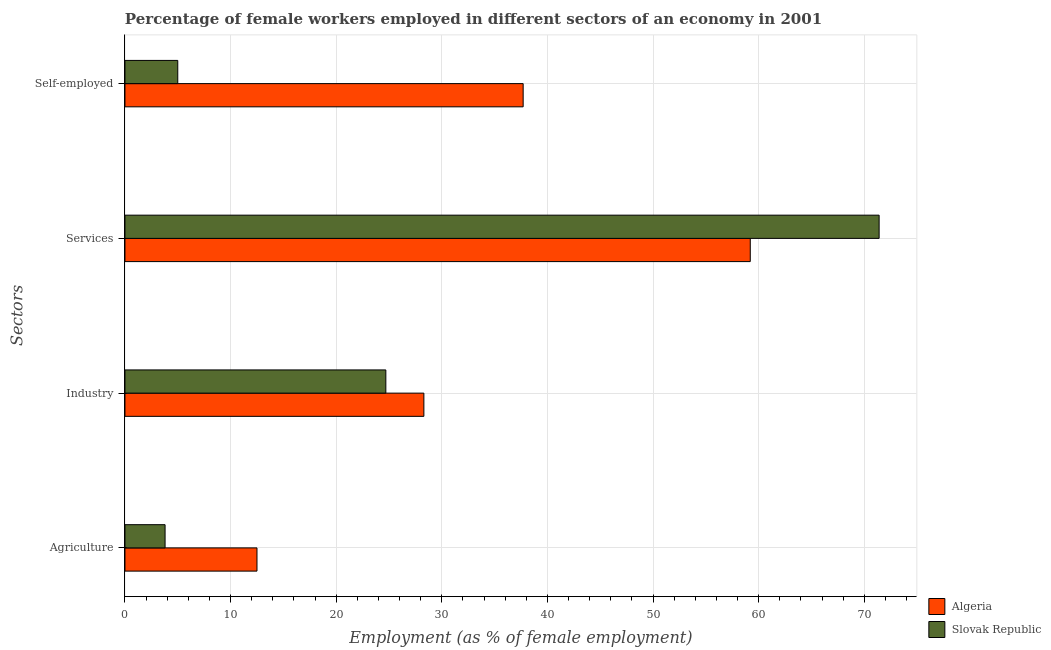How many different coloured bars are there?
Keep it short and to the point. 2. How many groups of bars are there?
Provide a succinct answer. 4. Are the number of bars per tick equal to the number of legend labels?
Keep it short and to the point. Yes. How many bars are there on the 2nd tick from the bottom?
Make the answer very short. 2. What is the label of the 1st group of bars from the top?
Give a very brief answer. Self-employed. What is the percentage of female workers in services in Algeria?
Provide a succinct answer. 59.2. Across all countries, what is the maximum percentage of female workers in agriculture?
Give a very brief answer. 12.5. In which country was the percentage of female workers in agriculture maximum?
Your answer should be compact. Algeria. In which country was the percentage of female workers in agriculture minimum?
Give a very brief answer. Slovak Republic. What is the total percentage of self employed female workers in the graph?
Your response must be concise. 42.7. What is the difference between the percentage of female workers in agriculture in Slovak Republic and that in Algeria?
Offer a terse response. -8.7. What is the difference between the percentage of self employed female workers in Slovak Republic and the percentage of female workers in services in Algeria?
Ensure brevity in your answer.  -54.2. What is the average percentage of female workers in services per country?
Your answer should be compact. 65.3. What is the difference between the percentage of self employed female workers and percentage of female workers in industry in Algeria?
Make the answer very short. 9.4. In how many countries, is the percentage of female workers in services greater than 4 %?
Make the answer very short. 2. What is the ratio of the percentage of female workers in industry in Algeria to that in Slovak Republic?
Provide a succinct answer. 1.15. What is the difference between the highest and the second highest percentage of self employed female workers?
Give a very brief answer. 32.7. What is the difference between the highest and the lowest percentage of self employed female workers?
Your answer should be very brief. 32.7. Is it the case that in every country, the sum of the percentage of female workers in agriculture and percentage of self employed female workers is greater than the sum of percentage of female workers in services and percentage of female workers in industry?
Make the answer very short. No. What does the 2nd bar from the top in Industry represents?
Your answer should be very brief. Algeria. What does the 1st bar from the bottom in Agriculture represents?
Provide a succinct answer. Algeria. Is it the case that in every country, the sum of the percentage of female workers in agriculture and percentage of female workers in industry is greater than the percentage of female workers in services?
Make the answer very short. No. How many countries are there in the graph?
Provide a succinct answer. 2. What is the difference between two consecutive major ticks on the X-axis?
Make the answer very short. 10. Does the graph contain any zero values?
Offer a terse response. No. How many legend labels are there?
Make the answer very short. 2. How are the legend labels stacked?
Your answer should be very brief. Vertical. What is the title of the graph?
Your answer should be very brief. Percentage of female workers employed in different sectors of an economy in 2001. What is the label or title of the X-axis?
Ensure brevity in your answer.  Employment (as % of female employment). What is the label or title of the Y-axis?
Keep it short and to the point. Sectors. What is the Employment (as % of female employment) in Algeria in Agriculture?
Offer a terse response. 12.5. What is the Employment (as % of female employment) of Slovak Republic in Agriculture?
Keep it short and to the point. 3.8. What is the Employment (as % of female employment) in Algeria in Industry?
Ensure brevity in your answer.  28.3. What is the Employment (as % of female employment) in Slovak Republic in Industry?
Your response must be concise. 24.7. What is the Employment (as % of female employment) of Algeria in Services?
Offer a terse response. 59.2. What is the Employment (as % of female employment) in Slovak Republic in Services?
Provide a short and direct response. 71.4. What is the Employment (as % of female employment) in Algeria in Self-employed?
Your response must be concise. 37.7. Across all Sectors, what is the maximum Employment (as % of female employment) of Algeria?
Your response must be concise. 59.2. Across all Sectors, what is the maximum Employment (as % of female employment) of Slovak Republic?
Provide a short and direct response. 71.4. Across all Sectors, what is the minimum Employment (as % of female employment) in Slovak Republic?
Offer a terse response. 3.8. What is the total Employment (as % of female employment) of Algeria in the graph?
Your answer should be compact. 137.7. What is the total Employment (as % of female employment) in Slovak Republic in the graph?
Your answer should be compact. 104.9. What is the difference between the Employment (as % of female employment) in Algeria in Agriculture and that in Industry?
Keep it short and to the point. -15.8. What is the difference between the Employment (as % of female employment) in Slovak Republic in Agriculture and that in Industry?
Provide a short and direct response. -20.9. What is the difference between the Employment (as % of female employment) in Algeria in Agriculture and that in Services?
Offer a very short reply. -46.7. What is the difference between the Employment (as % of female employment) of Slovak Republic in Agriculture and that in Services?
Your answer should be compact. -67.6. What is the difference between the Employment (as % of female employment) of Algeria in Agriculture and that in Self-employed?
Offer a terse response. -25.2. What is the difference between the Employment (as % of female employment) in Slovak Republic in Agriculture and that in Self-employed?
Provide a short and direct response. -1.2. What is the difference between the Employment (as % of female employment) in Algeria in Industry and that in Services?
Your answer should be compact. -30.9. What is the difference between the Employment (as % of female employment) of Slovak Republic in Industry and that in Services?
Keep it short and to the point. -46.7. What is the difference between the Employment (as % of female employment) of Algeria in Industry and that in Self-employed?
Provide a succinct answer. -9.4. What is the difference between the Employment (as % of female employment) of Slovak Republic in Industry and that in Self-employed?
Make the answer very short. 19.7. What is the difference between the Employment (as % of female employment) of Algeria in Services and that in Self-employed?
Your answer should be compact. 21.5. What is the difference between the Employment (as % of female employment) in Slovak Republic in Services and that in Self-employed?
Provide a short and direct response. 66.4. What is the difference between the Employment (as % of female employment) of Algeria in Agriculture and the Employment (as % of female employment) of Slovak Republic in Services?
Make the answer very short. -58.9. What is the difference between the Employment (as % of female employment) of Algeria in Agriculture and the Employment (as % of female employment) of Slovak Republic in Self-employed?
Keep it short and to the point. 7.5. What is the difference between the Employment (as % of female employment) of Algeria in Industry and the Employment (as % of female employment) of Slovak Republic in Services?
Ensure brevity in your answer.  -43.1. What is the difference between the Employment (as % of female employment) in Algeria in Industry and the Employment (as % of female employment) in Slovak Republic in Self-employed?
Provide a short and direct response. 23.3. What is the difference between the Employment (as % of female employment) in Algeria in Services and the Employment (as % of female employment) in Slovak Republic in Self-employed?
Ensure brevity in your answer.  54.2. What is the average Employment (as % of female employment) in Algeria per Sectors?
Your response must be concise. 34.42. What is the average Employment (as % of female employment) of Slovak Republic per Sectors?
Provide a short and direct response. 26.23. What is the difference between the Employment (as % of female employment) of Algeria and Employment (as % of female employment) of Slovak Republic in Agriculture?
Offer a terse response. 8.7. What is the difference between the Employment (as % of female employment) of Algeria and Employment (as % of female employment) of Slovak Republic in Self-employed?
Make the answer very short. 32.7. What is the ratio of the Employment (as % of female employment) of Algeria in Agriculture to that in Industry?
Give a very brief answer. 0.44. What is the ratio of the Employment (as % of female employment) of Slovak Republic in Agriculture to that in Industry?
Keep it short and to the point. 0.15. What is the ratio of the Employment (as % of female employment) of Algeria in Agriculture to that in Services?
Ensure brevity in your answer.  0.21. What is the ratio of the Employment (as % of female employment) of Slovak Republic in Agriculture to that in Services?
Your answer should be compact. 0.05. What is the ratio of the Employment (as % of female employment) of Algeria in Agriculture to that in Self-employed?
Your answer should be very brief. 0.33. What is the ratio of the Employment (as % of female employment) of Slovak Republic in Agriculture to that in Self-employed?
Provide a short and direct response. 0.76. What is the ratio of the Employment (as % of female employment) in Algeria in Industry to that in Services?
Keep it short and to the point. 0.48. What is the ratio of the Employment (as % of female employment) in Slovak Republic in Industry to that in Services?
Keep it short and to the point. 0.35. What is the ratio of the Employment (as % of female employment) of Algeria in Industry to that in Self-employed?
Ensure brevity in your answer.  0.75. What is the ratio of the Employment (as % of female employment) in Slovak Republic in Industry to that in Self-employed?
Your answer should be very brief. 4.94. What is the ratio of the Employment (as % of female employment) of Algeria in Services to that in Self-employed?
Offer a very short reply. 1.57. What is the ratio of the Employment (as % of female employment) in Slovak Republic in Services to that in Self-employed?
Ensure brevity in your answer.  14.28. What is the difference between the highest and the second highest Employment (as % of female employment) in Algeria?
Give a very brief answer. 21.5. What is the difference between the highest and the second highest Employment (as % of female employment) in Slovak Republic?
Your answer should be compact. 46.7. What is the difference between the highest and the lowest Employment (as % of female employment) in Algeria?
Your response must be concise. 46.7. What is the difference between the highest and the lowest Employment (as % of female employment) in Slovak Republic?
Ensure brevity in your answer.  67.6. 